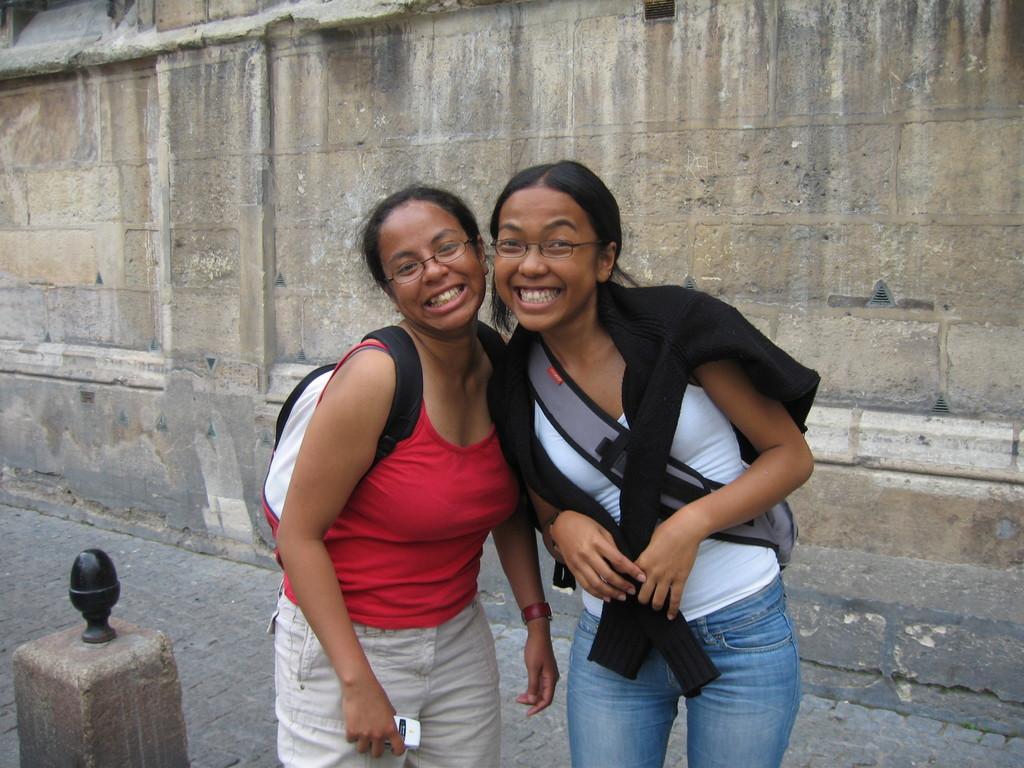Please provide a concise description of this image. In this image there are two women one is wearing red T-shirt, grey color pant and another one is wearing white T-shirt and blue jeans they are smiling and posing to a photograph in the life there is a small pillar in the background there is a wall. 